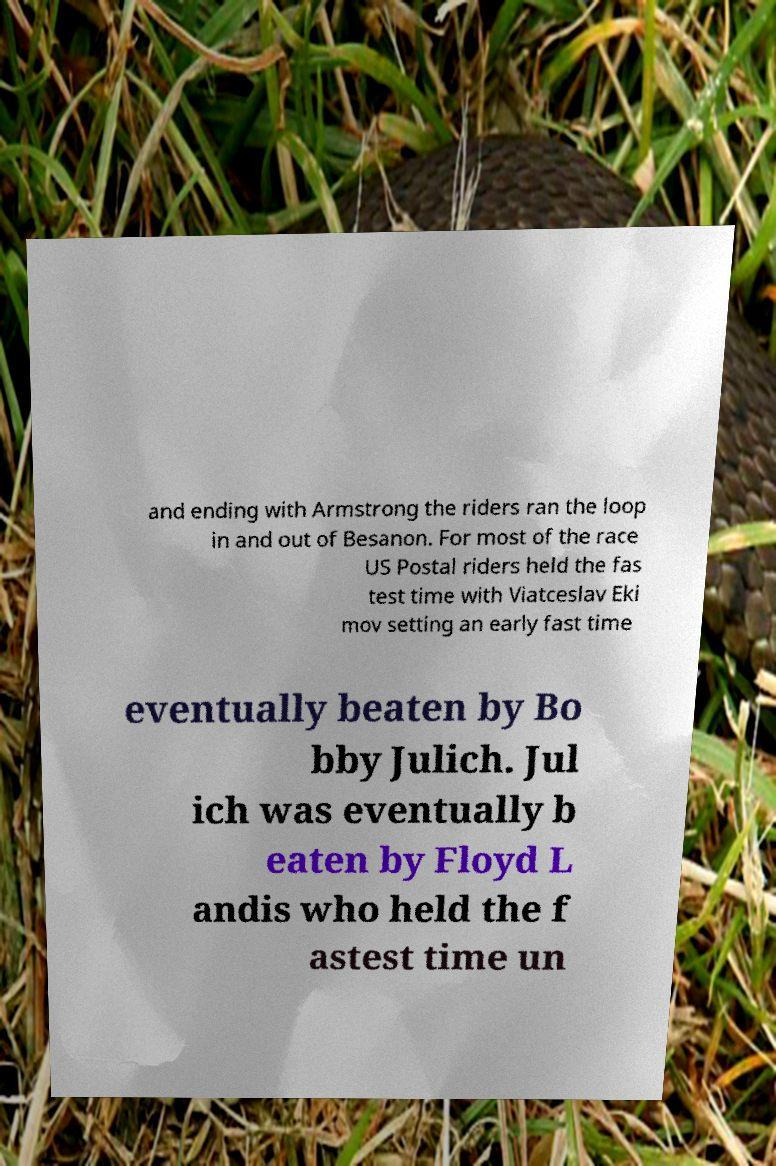Could you assist in decoding the text presented in this image and type it out clearly? and ending with Armstrong the riders ran the loop in and out of Besanon. For most of the race US Postal riders held the fas test time with Viatceslav Eki mov setting an early fast time eventually beaten by Bo bby Julich. Jul ich was eventually b eaten by Floyd L andis who held the f astest time un 